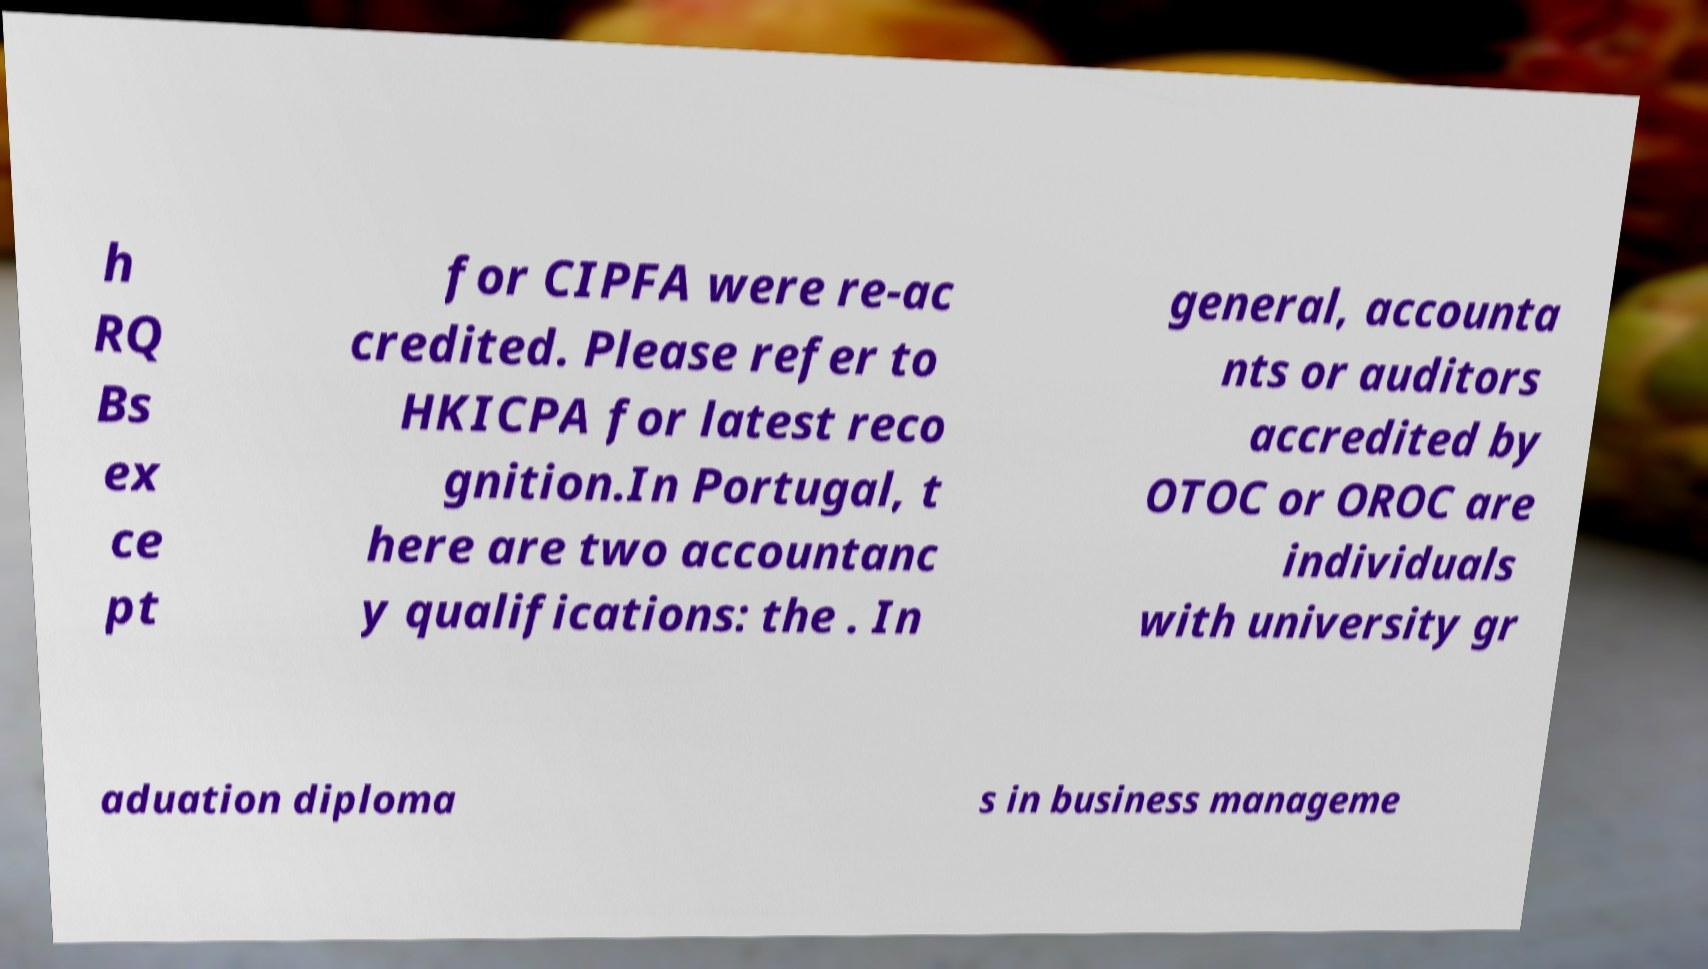Can you read and provide the text displayed in the image?This photo seems to have some interesting text. Can you extract and type it out for me? h RQ Bs ex ce pt for CIPFA were re-ac credited. Please refer to HKICPA for latest reco gnition.In Portugal, t here are two accountanc y qualifications: the . In general, accounta nts or auditors accredited by OTOC or OROC are individuals with university gr aduation diploma s in business manageme 